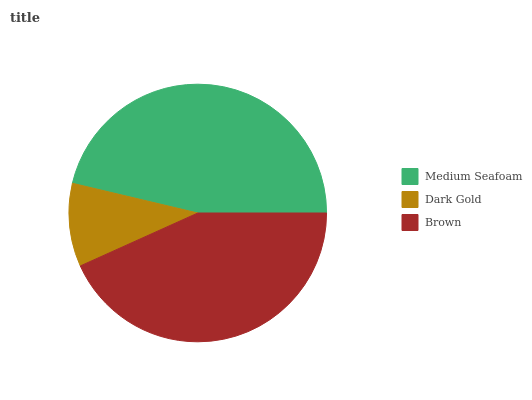Is Dark Gold the minimum?
Answer yes or no. Yes. Is Medium Seafoam the maximum?
Answer yes or no. Yes. Is Brown the minimum?
Answer yes or no. No. Is Brown the maximum?
Answer yes or no. No. Is Brown greater than Dark Gold?
Answer yes or no. Yes. Is Dark Gold less than Brown?
Answer yes or no. Yes. Is Dark Gold greater than Brown?
Answer yes or no. No. Is Brown less than Dark Gold?
Answer yes or no. No. Is Brown the high median?
Answer yes or no. Yes. Is Brown the low median?
Answer yes or no. Yes. Is Dark Gold the high median?
Answer yes or no. No. Is Medium Seafoam the low median?
Answer yes or no. No. 